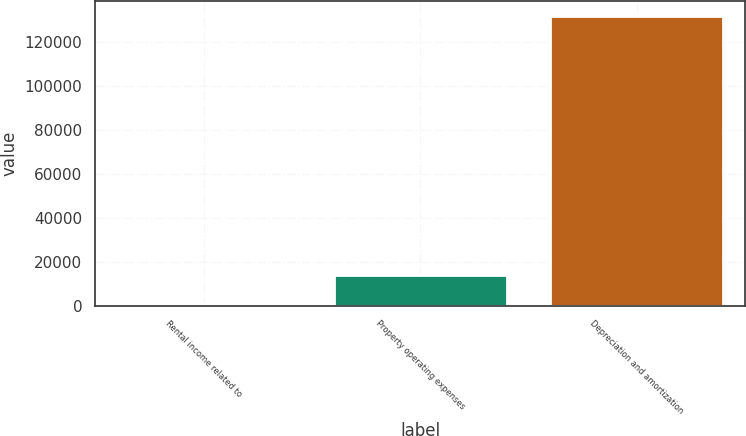Convert chart. <chart><loc_0><loc_0><loc_500><loc_500><bar_chart><fcel>Rental income related to<fcel>Property operating expenses<fcel>Depreciation and amortization<nl><fcel>919<fcel>14041.2<fcel>132141<nl></chart> 